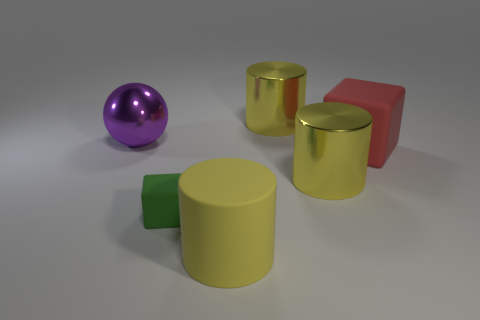Is there a big yellow object that is on the left side of the large yellow shiny object in front of the metallic object that is left of the large rubber cylinder?
Keep it short and to the point. Yes. The sphere has what size?
Ensure brevity in your answer.  Large. What number of cylinders are the same size as the red thing?
Provide a succinct answer. 3. There is a large red object that is the same shape as the green object; what is its material?
Provide a succinct answer. Rubber. There is a matte thing that is in front of the large red cube and on the right side of the tiny green block; what shape is it?
Your answer should be compact. Cylinder. The thing that is left of the small block has what shape?
Keep it short and to the point. Sphere. What number of big objects are left of the green cube and in front of the purple object?
Give a very brief answer. 0. Do the purple sphere and the cylinder behind the big red rubber thing have the same size?
Give a very brief answer. Yes. How big is the block to the left of the yellow cylinder that is left of the yellow cylinder that is behind the large purple shiny ball?
Provide a succinct answer. Small. There is a metal thing that is to the left of the small object; how big is it?
Your answer should be compact. Large. 